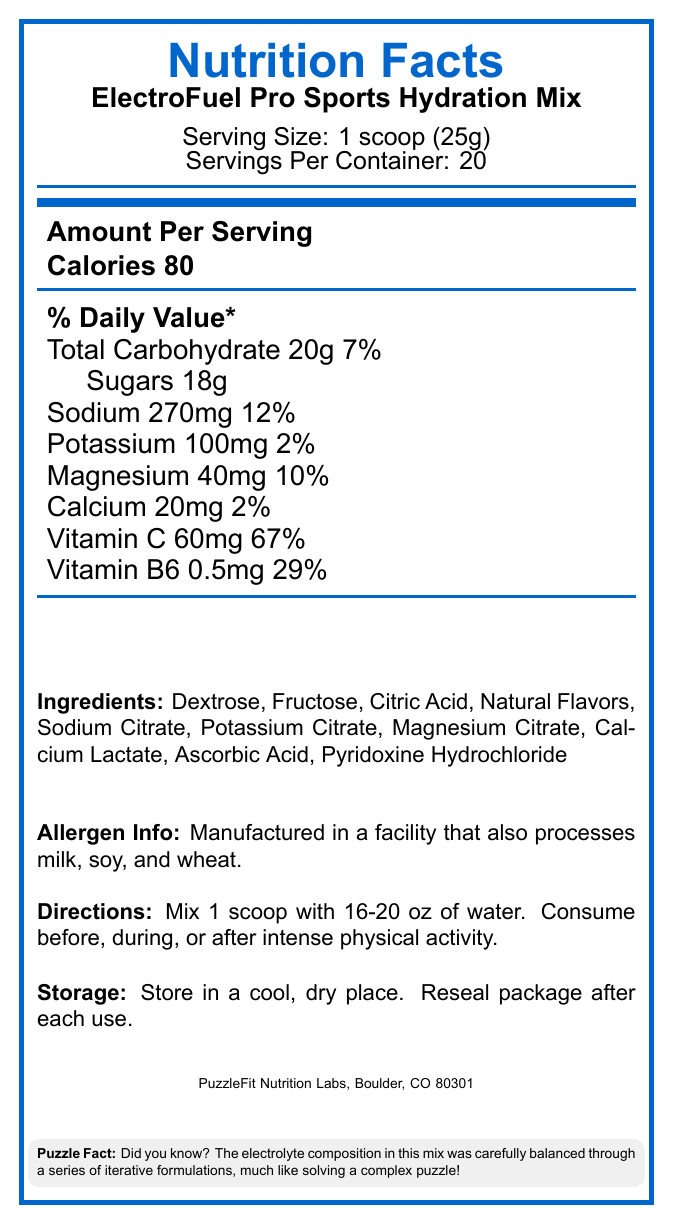what is the serving size for the ElectroFuel Pro Sports Hydration Mix? The document states that the serving size is 1 scoop, equivalent to 25 grams.
Answer: 1 scoop (25g) how many calories are there per serving? The document lists the amount per serving, and it mentions that there are 80 calories per serving.
Answer: 80 calories how much vitamin C is in each serving? The document shows that each serving contains 60 mg of vitamin C.
Answer: 60mg what are the main ingredients in the ElectroFuel Pro Sports Hydration Mix? The document provides a list of ingredients including Dextrose, Fructose, Citric Acid, and others.
Answer: Dextrose, Fructose, Citric Acid, Natural Flavors, Sodium Citrate, Potassium Citrate, Magnesium Citrate, Calcium Lactate, Ascorbic Acid, Pyridoxine Hydrochloride how many servings are there in one container? The document states that there are 20 servings per container.
Answer: 20 servings What percentage of the daily value for magnesium does one serving provide? A. 2% B. 10% C. 29% D. 67% The document indicates that each serving contains 40mg of magnesium, which is 10% of the daily value.
Answer: B. 10% Which vitamin has the highest percentage of the daily value in one serving? A. Vitamin C B. Vitamin B6 C. Calcium D. Magnesium The document shows that vitamin C provides 67% of the daily value per serving, which is the highest percentage among the listed vitamins and minerals.
Answer: A. Vitamin C Is this product suitable for individuals with milk, soy, and wheat allergies? The document mentions that the product is manufactured in a facility that also processes milk, soy, and wheat, indicating potential cross-contamination.
Answer: No Summarize the main idea of the Nutrition Facts Label for ElectroFuel Pro Sports Hydration Mix. The document provides detailed nutritional information, serving size, ingredients, allergen info, directions for use, and storage instructions for the product.
Answer: ElectroFuel Pro Sports Hydration Mix is a sports hydration powder mix designed to be consumed before, during, or after intense physical activity. Each serving is 1 scoop (25g) and contains 80 calories, 20g of carbohydrates, 18g of sugars, and various electrolytes and vitamins. It provides significant daily values for sodium, magnesium, vitamin C, and vitamin B6. The product is manufactured in a facility that processes milk, soy, and wheat. Consumers are advised to store it in a cool, dry place. Are there any directions on how to prepare the ElectroFuel Pro Sports Hydration Mix? The directions specify to mix 1 scoop with 16-20 oz of water and consume before, during, or after intense physical activity.
Answer: Yes What is the purpose of the "Puzzle Fact" included on the label? The document includes a "Puzzle Fact" that mentions the electrolyte composition was balanced through a series of iterative formulations, drawing a parallel to solving a complex puzzle.
Answer: To provide an interesting fact about the product's formulation process What is the weight of one serving in grams? The serving size is indicated as 1 scoop, which is equivalent to 25 grams.
Answer: 25 grams What is the total amount of carbohydrates per serving, and what percentage of the daily value does it represent? The document states that each serving contains 20g of total carbohydrates, which is 7% of the daily value.
Answer: 20g, 7% Does the document provide specific information about protein content? The document does not mention any information regarding protein content; therefore, it cannot be determined.
Answer: No 